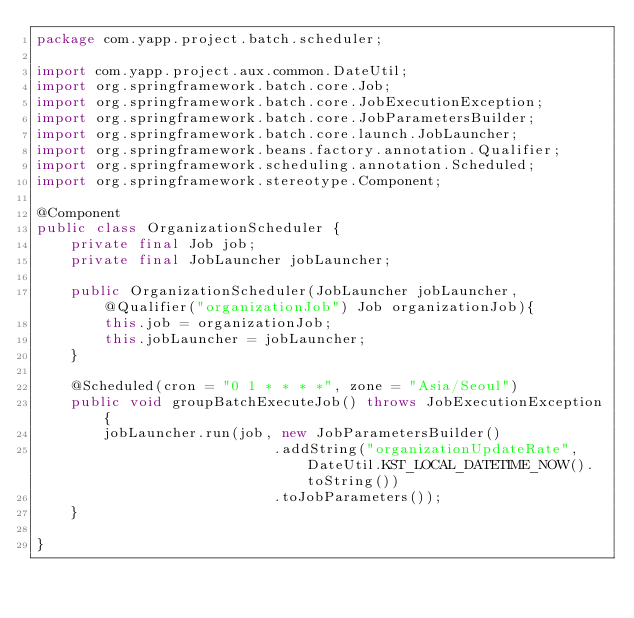<code> <loc_0><loc_0><loc_500><loc_500><_Java_>package com.yapp.project.batch.scheduler;

import com.yapp.project.aux.common.DateUtil;
import org.springframework.batch.core.Job;
import org.springframework.batch.core.JobExecutionException;
import org.springframework.batch.core.JobParametersBuilder;
import org.springframework.batch.core.launch.JobLauncher;
import org.springframework.beans.factory.annotation.Qualifier;
import org.springframework.scheduling.annotation.Scheduled;
import org.springframework.stereotype.Component;

@Component
public class OrganizationScheduler {
    private final Job job;
    private final JobLauncher jobLauncher;

    public OrganizationScheduler(JobLauncher jobLauncher, @Qualifier("organizationJob") Job organizationJob){
        this.job = organizationJob;
        this.jobLauncher = jobLauncher;
    }

    @Scheduled(cron = "0 1 * * * *", zone = "Asia/Seoul")
    public void groupBatchExecuteJob() throws JobExecutionException{
        jobLauncher.run(job, new JobParametersBuilder()
                            .addString("organizationUpdateRate", DateUtil.KST_LOCAL_DATETIME_NOW().toString())
                            .toJobParameters());
    }

}
</code> 